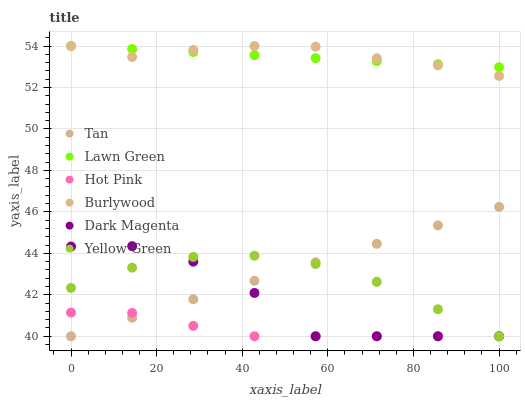Does Hot Pink have the minimum area under the curve?
Answer yes or no. Yes. Does Burlywood have the maximum area under the curve?
Answer yes or no. Yes. Does Dark Magenta have the minimum area under the curve?
Answer yes or no. No. Does Dark Magenta have the maximum area under the curve?
Answer yes or no. No. Is Lawn Green the smoothest?
Answer yes or no. Yes. Is Dark Magenta the roughest?
Answer yes or no. Yes. Is Burlywood the smoothest?
Answer yes or no. No. Is Burlywood the roughest?
Answer yes or no. No. Does Dark Magenta have the lowest value?
Answer yes or no. Yes. Does Burlywood have the lowest value?
Answer yes or no. No. Does Burlywood have the highest value?
Answer yes or no. Yes. Does Dark Magenta have the highest value?
Answer yes or no. No. Is Yellow Green less than Burlywood?
Answer yes or no. Yes. Is Lawn Green greater than Tan?
Answer yes or no. Yes. Does Yellow Green intersect Tan?
Answer yes or no. Yes. Is Yellow Green less than Tan?
Answer yes or no. No. Is Yellow Green greater than Tan?
Answer yes or no. No. Does Yellow Green intersect Burlywood?
Answer yes or no. No. 